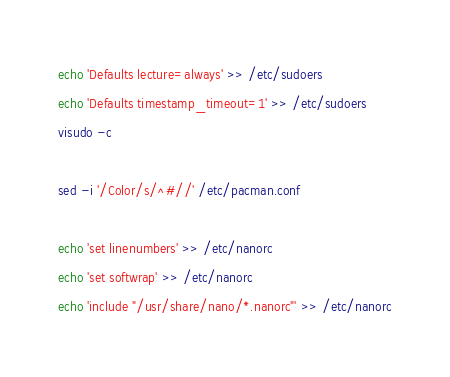<code> <loc_0><loc_0><loc_500><loc_500><_Bash_>echo 'Defaults lecture=always' >> /etc/sudoers
echo 'Defaults timestamp_timeout=1' >> /etc/sudoers
visudo -c

sed -i '/Color/s/^#//' /etc/pacman.conf

echo 'set linenumbers' >> /etc/nanorc
echo 'set softwrap' >> /etc/nanorc
echo 'include "/usr/share/nano/*.nanorc"' >> /etc/nanorc
</code> 